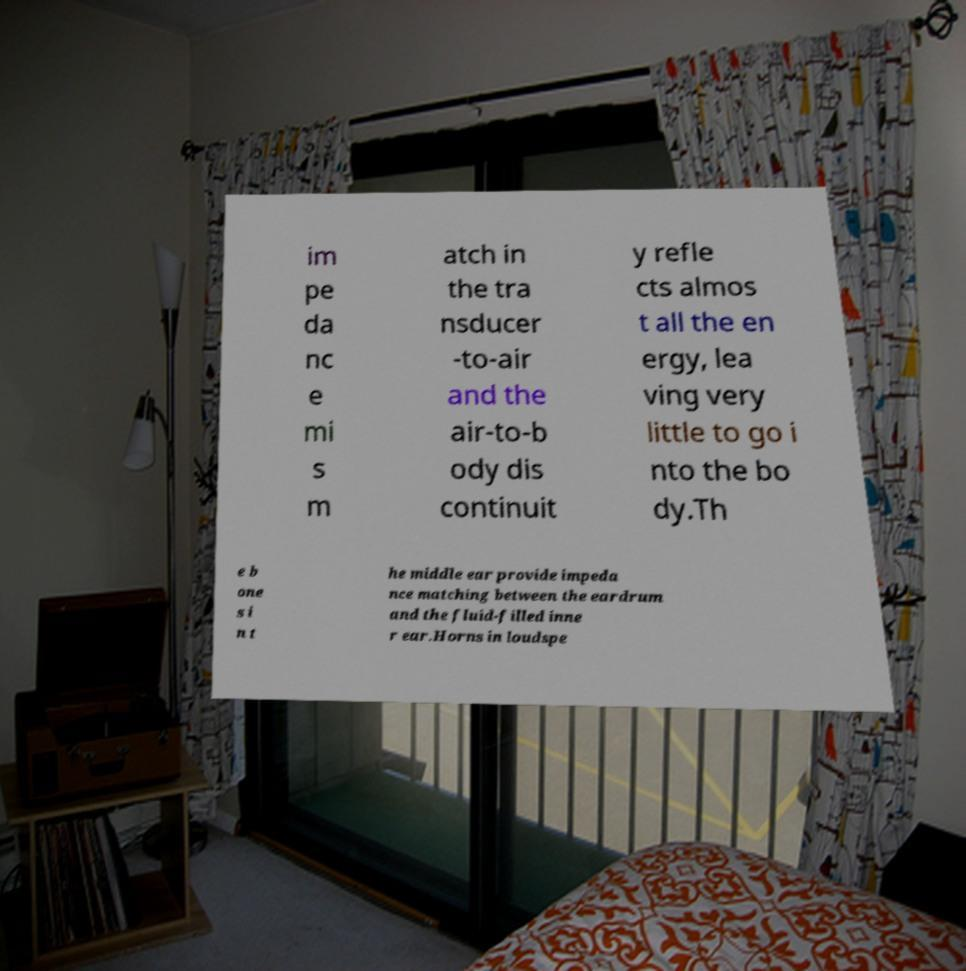Can you read and provide the text displayed in the image?This photo seems to have some interesting text. Can you extract and type it out for me? im pe da nc e mi s m atch in the tra nsducer -to-air and the air-to-b ody dis continuit y refle cts almos t all the en ergy, lea ving very little to go i nto the bo dy.Th e b one s i n t he middle ear provide impeda nce matching between the eardrum and the fluid-filled inne r ear.Horns in loudspe 